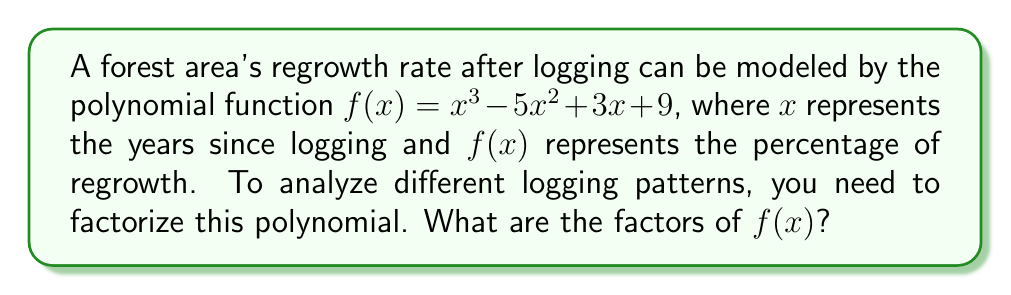Show me your answer to this math problem. To factorize the polynomial $f(x) = x^3 - 5x^2 + 3x + 9$, we'll follow these steps:

1) First, let's check if there are any rational roots using the rational root theorem. The possible rational roots are the factors of the constant term: $\pm 1, \pm 3, \pm 9$.

2) Testing these values, we find that $x = -1$ is a root of the polynomial.

3) We can factor out $(x + 1)$:

   $f(x) = (x + 1)(x^2 - 6x + 9)$

4) The quadratic factor $x^2 - 6x + 9$ can be factored further:

   $x^2 - 6x + 9 = (x - 3)^2$

5) Therefore, the complete factorization is:

   $f(x) = (x + 1)(x - 3)^2$

This factorization allows us to analyze different logging patterns:
- The factor $(x + 1)$ represents a linear component of regrowth.
- The factor $(x - 3)^2$ represents a quadratic component with a repeated root at $x = 3$, indicating a critical point in the regrowth process 3 years after logging.
Answer: $(x + 1)(x - 3)^2$ 